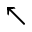Convert formula to latex. <formula><loc_0><loc_0><loc_500><loc_500>\nwarrow</formula> 